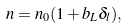Convert formula to latex. <formula><loc_0><loc_0><loc_500><loc_500>n = n _ { 0 } ( 1 + b _ { L } \delta _ { l } ) ,</formula> 